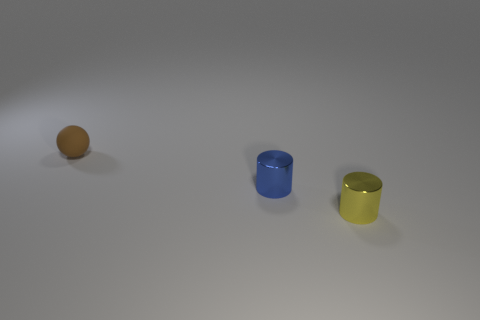How many other things are there of the same size as the rubber thing? There are two objects that appear to be of similar size to the rubber item: a blue cylinder and a yellow cylinder. 